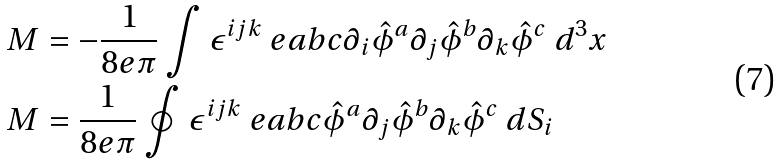Convert formula to latex. <formula><loc_0><loc_0><loc_500><loc_500>M & = - \frac { 1 } { 8 e \pi } \int \epsilon ^ { i j k } \ e a b c \partial _ { i } \hat { \phi } ^ { a } \partial _ { j } \hat { \phi } ^ { b } \partial _ { k } \hat { \phi } ^ { c } \ d ^ { 3 } x \\ M & = \frac { 1 } { 8 e \pi } \oint \epsilon ^ { i j k } \ e a b c \hat { \phi } ^ { a } \partial _ { j } \hat { \phi } ^ { b } \partial _ { k } \hat { \phi } ^ { c } \ d S _ { i }</formula> 